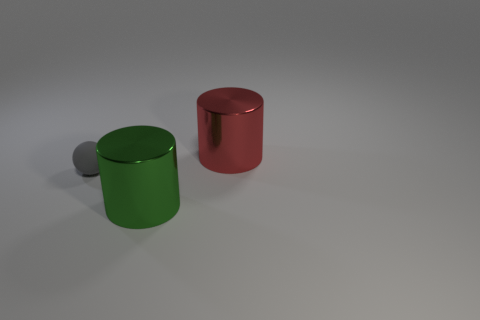Can you describe the overall composition and the elements present in the image? Certainly! The image presents a minimalist scene set against a neutral background, featuring two primary objects: a green metallic cylinder and a red metallic cylinder, both with a luster indicative of a metallic texture. In relation to these objects are three smaller gray spheres. One is positioned behind the red cylinder and two are behind the green cylinder, suggesting a deliberate arrangement for artistic or illustrative purposes. 